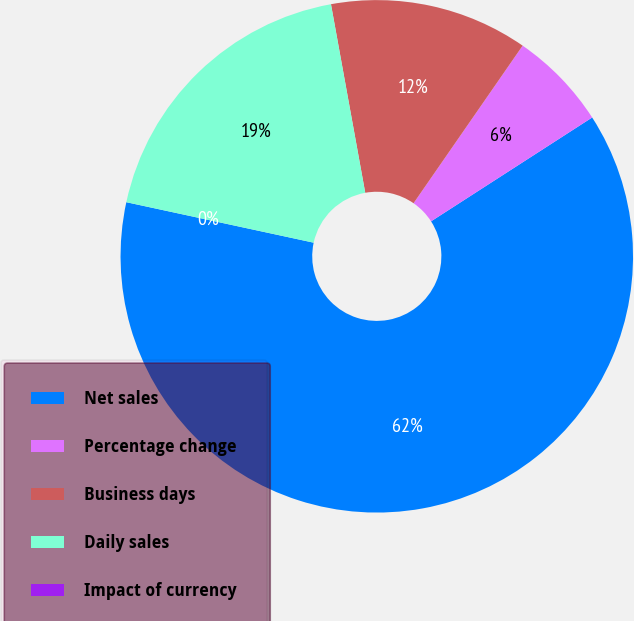<chart> <loc_0><loc_0><loc_500><loc_500><pie_chart><fcel>Net sales<fcel>Percentage change<fcel>Business days<fcel>Daily sales<fcel>Impact of currency<nl><fcel>62.5%<fcel>6.25%<fcel>12.5%<fcel>18.75%<fcel>0.0%<nl></chart> 